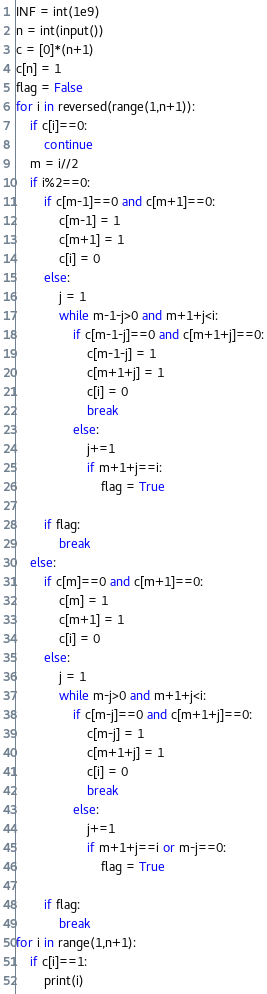Convert code to text. <code><loc_0><loc_0><loc_500><loc_500><_Python_>INF = int(1e9)
n = int(input())
c = [0]*(n+1)
c[n] = 1
flag = False
for i in reversed(range(1,n+1)):
    if c[i]==0:
        continue
    m = i//2
    if i%2==0:
        if c[m-1]==0 and c[m+1]==0:
            c[m-1] = 1
            c[m+1] = 1
            c[i] = 0
        else:
            j = 1
            while m-1-j>0 and m+1+j<i:
                if c[m-1-j]==0 and c[m+1+j]==0:
                    c[m-1-j] = 1
                    c[m+1+j] = 1
                    c[i] = 0
                    break
                else:
                    j+=1
                    if m+1+j==i:
                        flag = True
        
        if flag:
            break
    else:
        if c[m]==0 and c[m+1]==0:
            c[m] = 1
            c[m+1] = 1
            c[i] = 0
        else:
            j = 1
            while m-j>0 and m+1+j<i:
                if c[m-j]==0 and c[m+1+j]==0:
                    c[m-j] = 1
                    c[m+1+j] = 1
                    c[i] = 0
                    break
                else:
                    j+=1
                    if m+1+j==i or m-j==0:
                        flag = True
        
        if flag:
            break
for i in range(1,n+1):
    if c[i]==1:
        print(i)</code> 